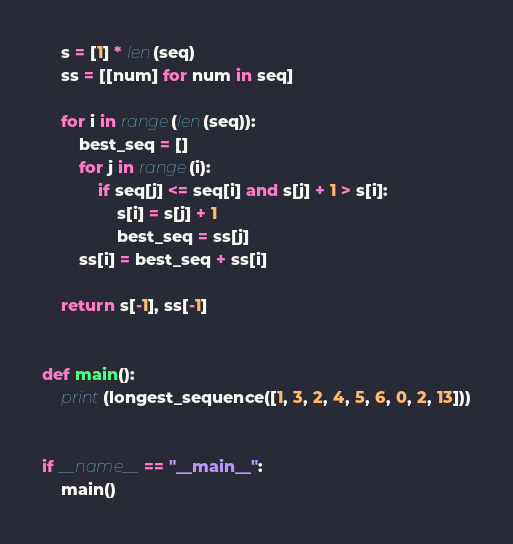<code> <loc_0><loc_0><loc_500><loc_500><_Python_>    s = [1] * len(seq)
    ss = [[num] for num in seq]

    for i in range(len(seq)):
        best_seq = []
        for j in range(i):
            if seq[j] <= seq[i] and s[j] + 1 > s[i]:
                s[i] = s[j] + 1
                best_seq = ss[j]
        ss[i] = best_seq + ss[i]

    return s[-1], ss[-1]


def main():
    print(longest_sequence([1, 3, 2, 4, 5, 6, 0, 2, 13]))


if __name__ == "__main__":
    main()
</code> 